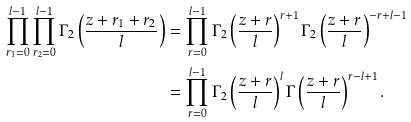Convert formula to latex. <formula><loc_0><loc_0><loc_500><loc_500>\prod _ { r _ { 1 } = 0 } ^ { l - 1 } \prod _ { r _ { 2 } = 0 } ^ { l - 1 } \Gamma _ { 2 } \left ( \frac { z + r _ { 1 } + r _ { 2 } } { l } \right ) & = \prod _ { r = 0 } ^ { l - 1 } \Gamma _ { 2 } \left ( \frac { z + r } { l } \right ) ^ { r + 1 } \Gamma _ { 2 } \left ( \frac { z + r } { l } \right ) ^ { - r + l - 1 } \\ & = \prod _ { r = 0 } ^ { l - 1 } \Gamma _ { 2 } \left ( \frac { z + r } { l } \right ) ^ { l } \Gamma \left ( \frac { z + r } { l } \right ) ^ { r - l + 1 } .</formula> 